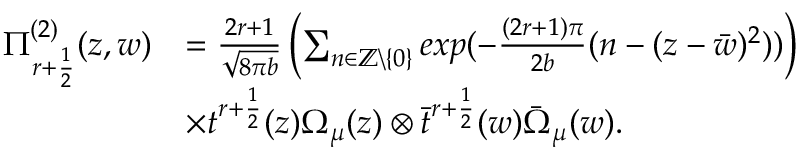<formula> <loc_0><loc_0><loc_500><loc_500>\begin{array} { r l } { \Pi _ { r + \frac { 1 } { 2 } } ^ { ( 2 ) } ( z , w ) } & { = \frac { 2 r + 1 } { \sqrt { 8 \pi b } } \left ( \sum _ { n \in \mathbb { Z } \ \{ 0 \} } e x p ( - \frac { ( 2 r + 1 ) \pi } { 2 b } ( n - ( z - \bar { w } ) ^ { 2 } ) ) \right ) } \\ & { \times t ^ { r + \frac { 1 } { 2 } } ( z ) \Omega _ { \mu } ( z ) \otimes \bar { t } ^ { r + \frac { 1 } { 2 } } ( w ) \bar { \Omega } _ { \mu } ( w ) . } \end{array}</formula> 